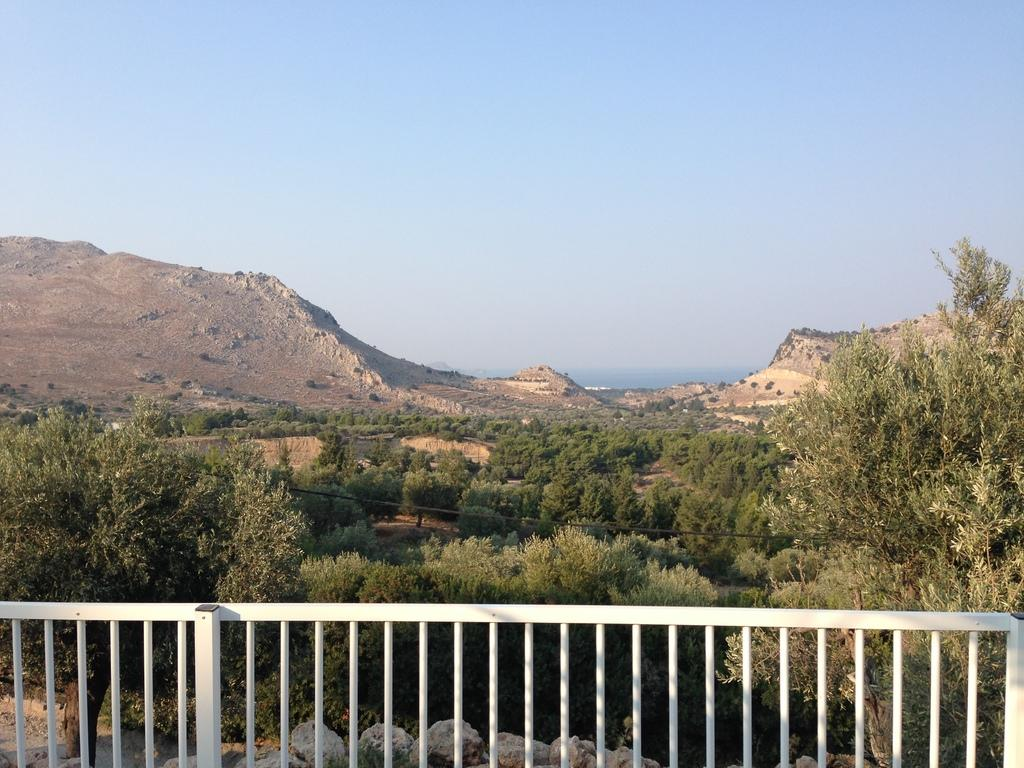What type of objects can be seen in the image? There are stones in the image. What is located in the front of the image? There is railing in the front of the image. What can be seen in the background of the image? There are trees, a wire, mountains, and the sky visible in the background of the image. What type of toys can be seen in the image? There are no toys present in the image. What is the alarm sounding like in the image? There is no alarm present in the image. 